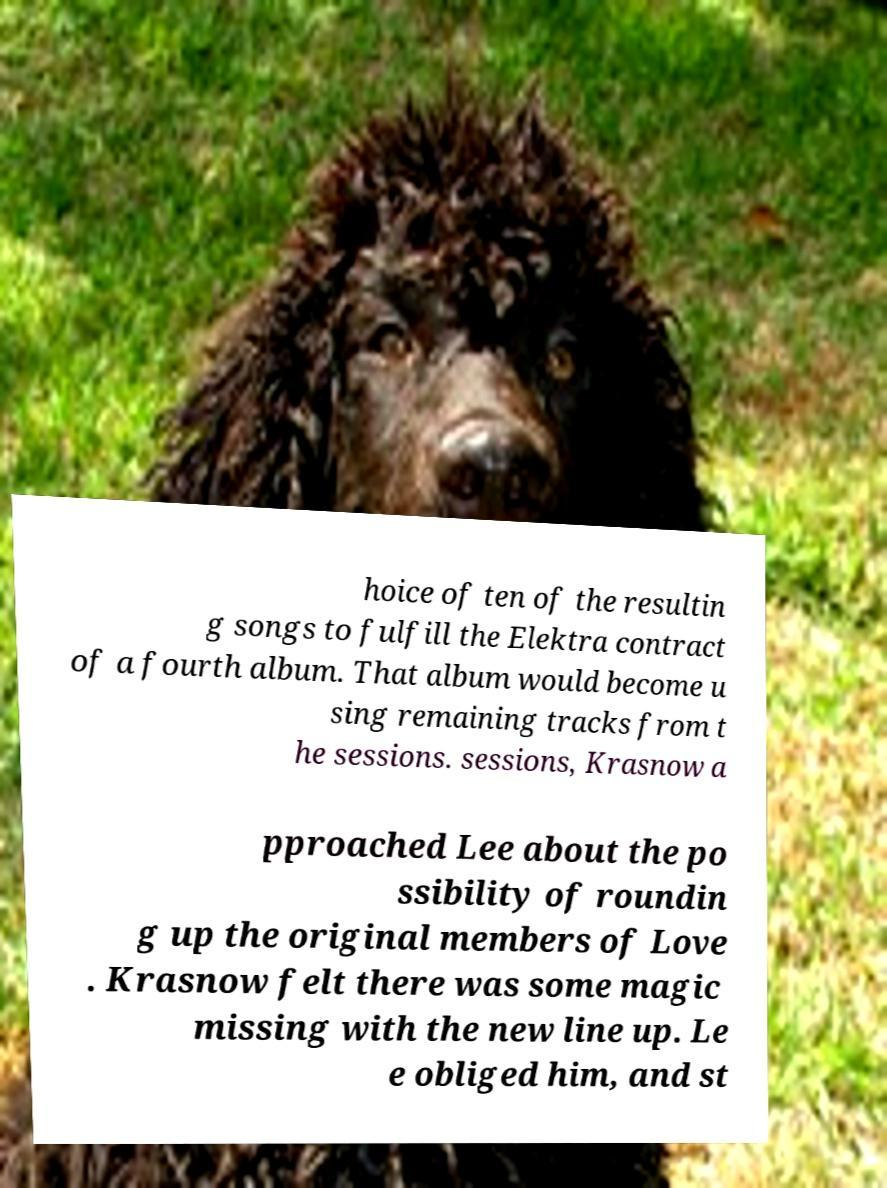Can you accurately transcribe the text from the provided image for me? hoice of ten of the resultin g songs to fulfill the Elektra contract of a fourth album. That album would become u sing remaining tracks from t he sessions. sessions, Krasnow a pproached Lee about the po ssibility of roundin g up the original members of Love . Krasnow felt there was some magic missing with the new line up. Le e obliged him, and st 